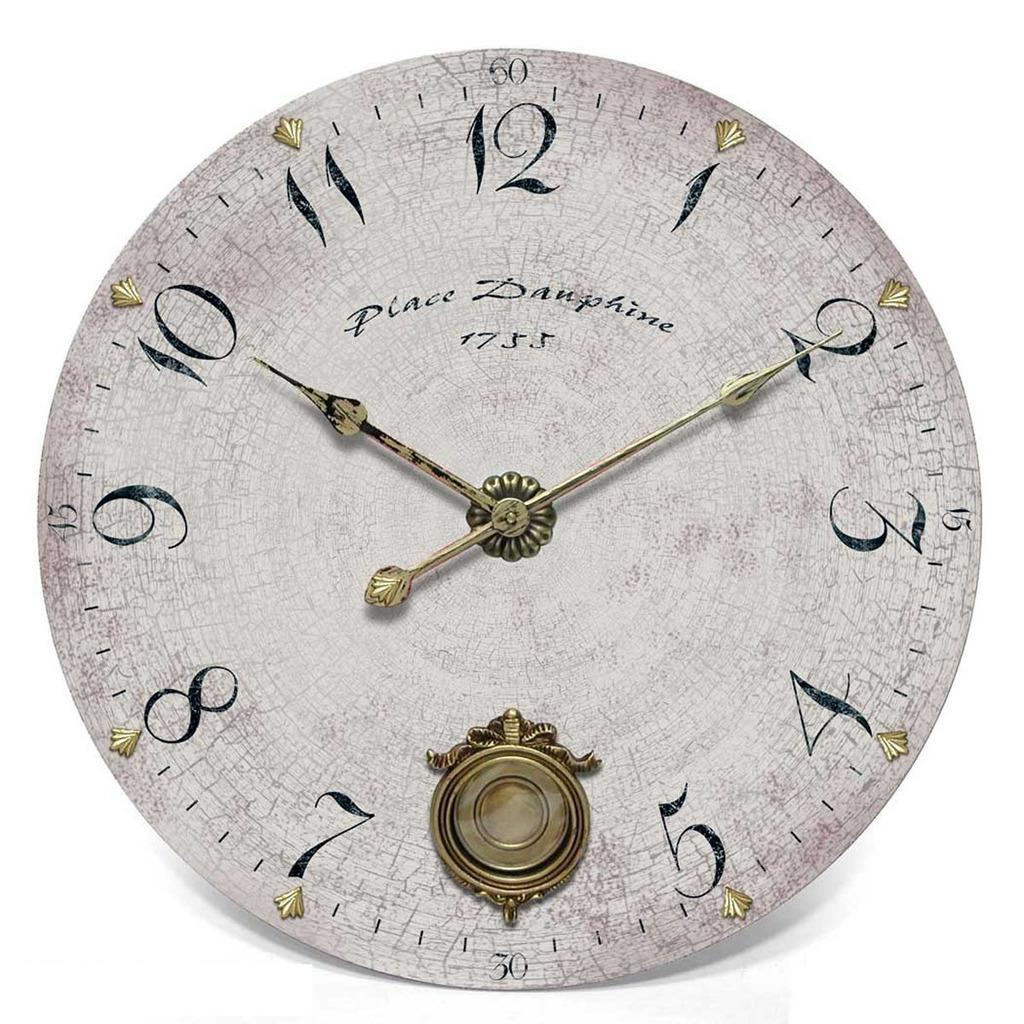What object in the image is used for telling time? There is a clock in the image that is used for telling time. Can you see any snakes slithering around the clock in the image? There are no snakes present in the image; it only features a clock. 